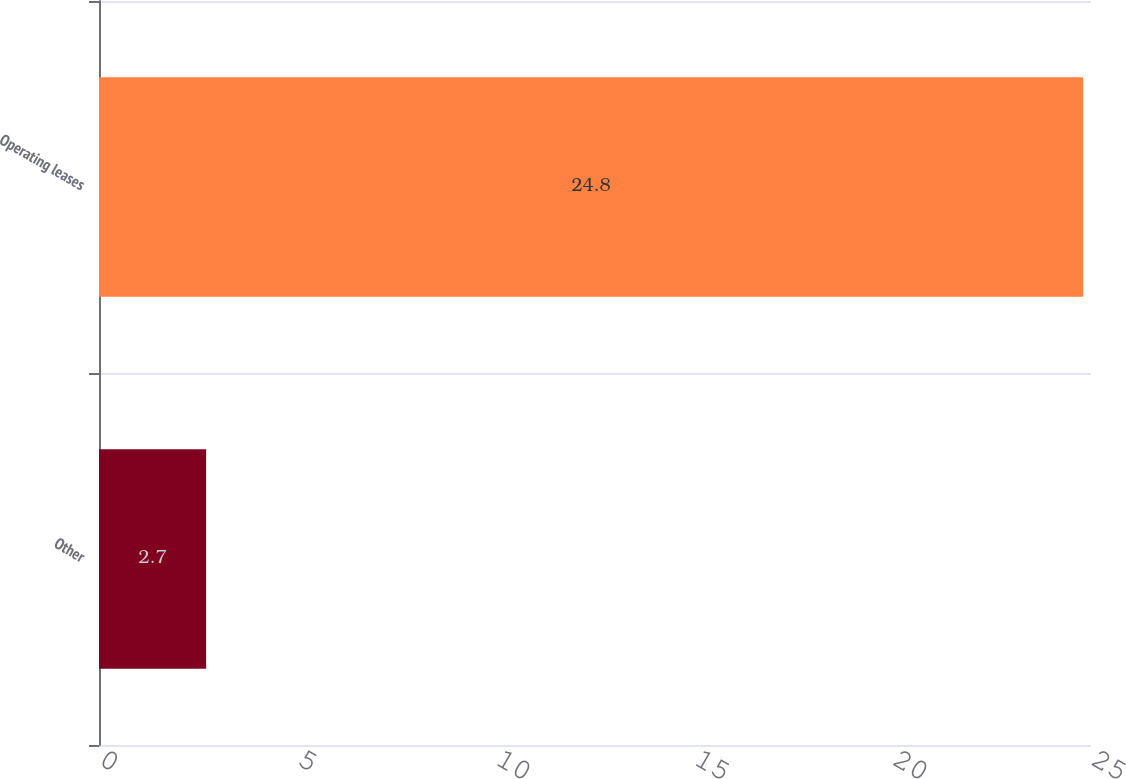Convert chart to OTSL. <chart><loc_0><loc_0><loc_500><loc_500><bar_chart><fcel>Other<fcel>Operating leases<nl><fcel>2.7<fcel>24.8<nl></chart> 